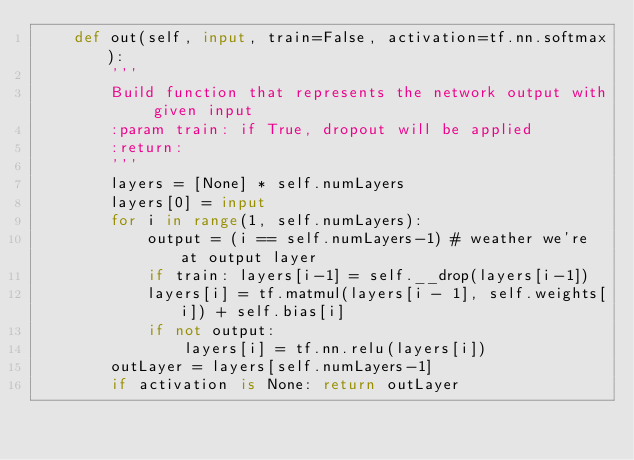<code> <loc_0><loc_0><loc_500><loc_500><_Python_>    def out(self, input, train=False, activation=tf.nn.softmax):
        '''
        Build function that represents the network output with given input
        :param train: if True, dropout will be applied
        :return:
        '''
        layers = [None] * self.numLayers
        layers[0] = input
        for i in range(1, self.numLayers):
            output = (i == self.numLayers-1) # weather we're at output layer
            if train: layers[i-1] = self.__drop(layers[i-1])
            layers[i] = tf.matmul(layers[i - 1], self.weights[i]) + self.bias[i]
            if not output:
                layers[i] = tf.nn.relu(layers[i])
        outLayer = layers[self.numLayers-1]
        if activation is None: return outLayer</code> 